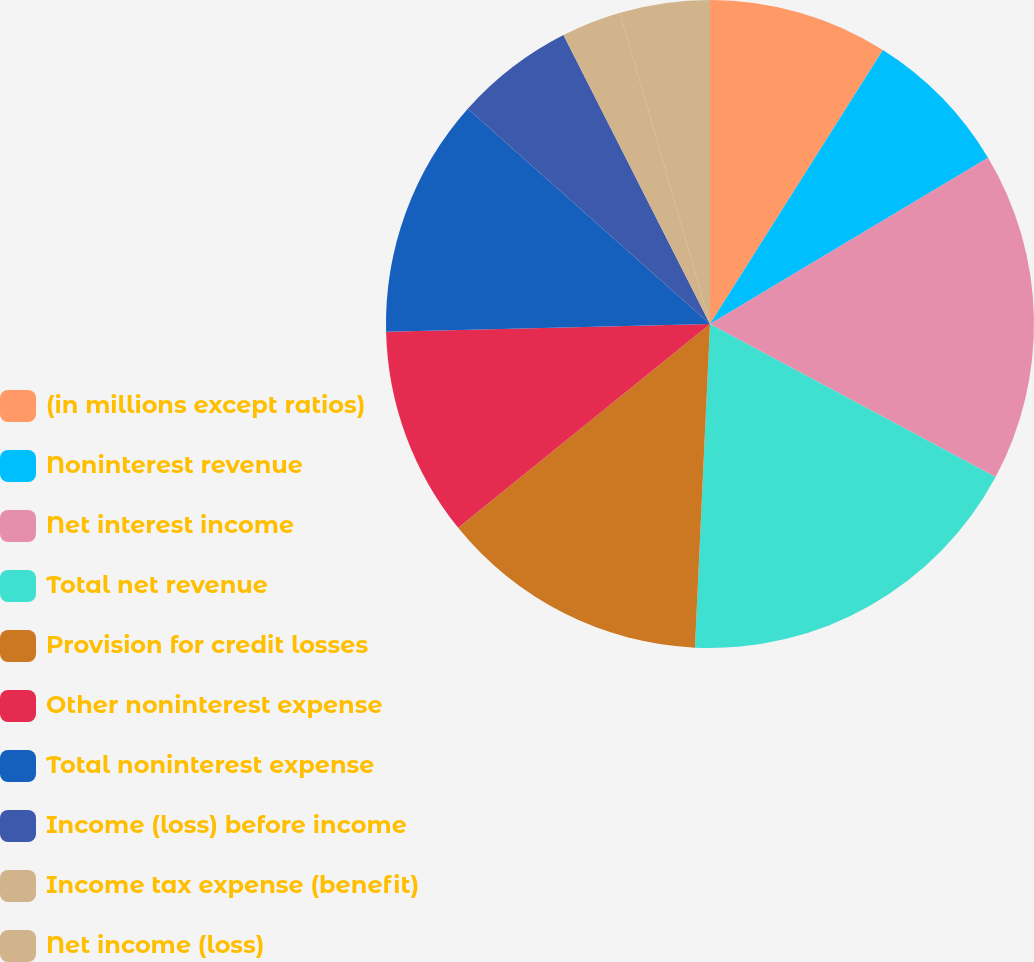Convert chart. <chart><loc_0><loc_0><loc_500><loc_500><pie_chart><fcel>(in millions except ratios)<fcel>Noninterest revenue<fcel>Net interest income<fcel>Total net revenue<fcel>Provision for credit losses<fcel>Other noninterest expense<fcel>Total noninterest expense<fcel>Income (loss) before income<fcel>Income tax expense (benefit)<fcel>Net income (loss)<nl><fcel>8.96%<fcel>7.46%<fcel>16.41%<fcel>17.91%<fcel>13.43%<fcel>10.45%<fcel>11.94%<fcel>5.97%<fcel>2.99%<fcel>4.48%<nl></chart> 